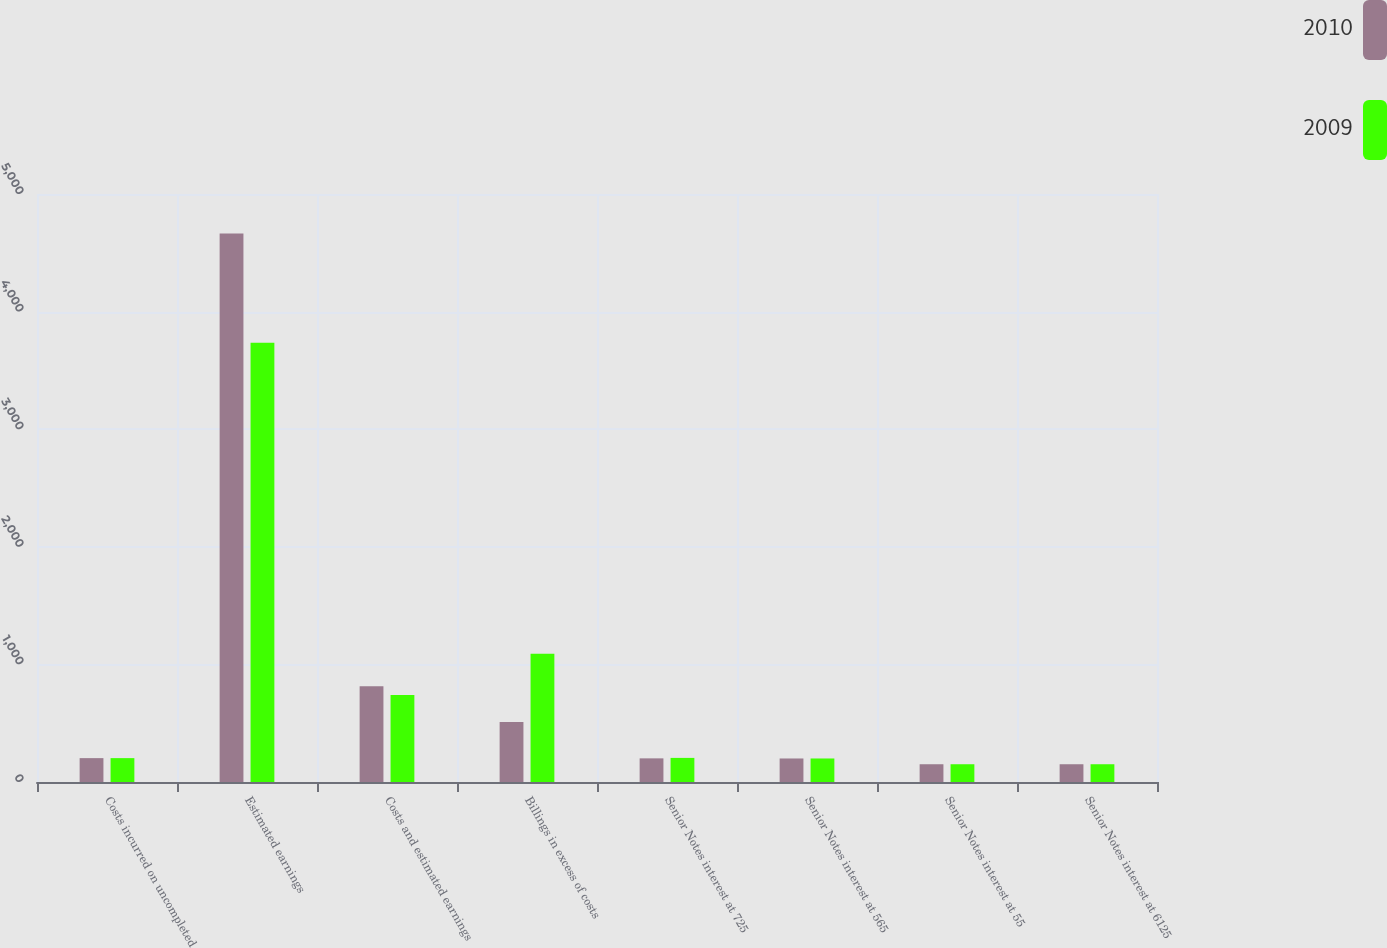Convert chart. <chart><loc_0><loc_0><loc_500><loc_500><stacked_bar_chart><ecel><fcel>Costs incurred on uncompleted<fcel>Estimated earnings<fcel>Costs and estimated earnings<fcel>Billings in excess of costs<fcel>Senior Notes interest at 725<fcel>Senior Notes interest at 565<fcel>Senior Notes interest at 55<fcel>Senior Notes interest at 6125<nl><fcel>2010<fcel>203<fcel>4665<fcel>815<fcel>511<fcel>201<fcel>200<fcel>151<fcel>151<nl><fcel>2009<fcel>203<fcel>3735<fcel>740<fcel>1090<fcel>205<fcel>200<fcel>151<fcel>151<nl></chart> 